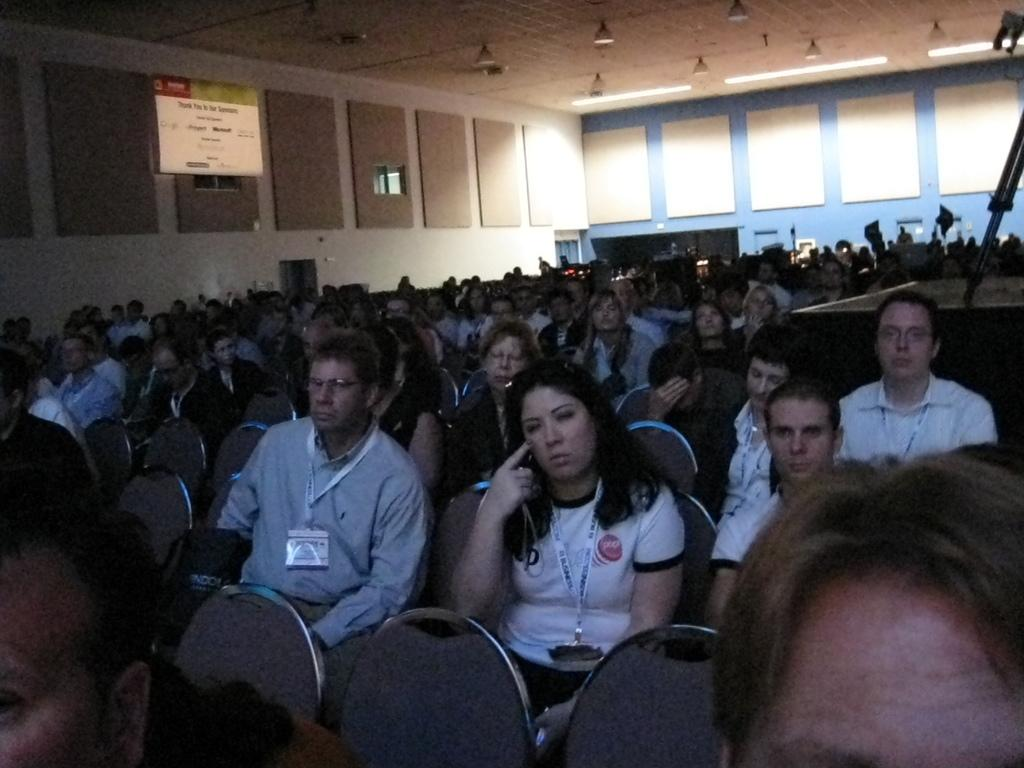What is happening in the image involving a group of people? There is a group of people in the image, and they are sitting on chairs. What can be seen in the image besides the people sitting on chairs? There is a banner in the image. What is visible in the background of the image? There are walls visible in the background of the image. Reasoning: Let' Let's think step by step in order to produce the conversation. We start by identifying the main subject in the image, which is the group of people. Then, we describe their actions, which is sitting on chairs. Next, we expand the conversation to include other items that are also visible, such as the banner. Finally, we mention the background of the image, which includes walls. Absurd Question/Answer: What type of brass instrument is being played by the person in the image? There is no brass instrument or person playing an instrument present in the image. Is there a veil covering any part of the image? No, there is no veil present in the image. 